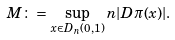Convert formula to latex. <formula><loc_0><loc_0><loc_500><loc_500>M \colon = \sup _ { x \in D _ { n } ( 0 , 1 ) } n | D \pi ( x ) | .</formula> 